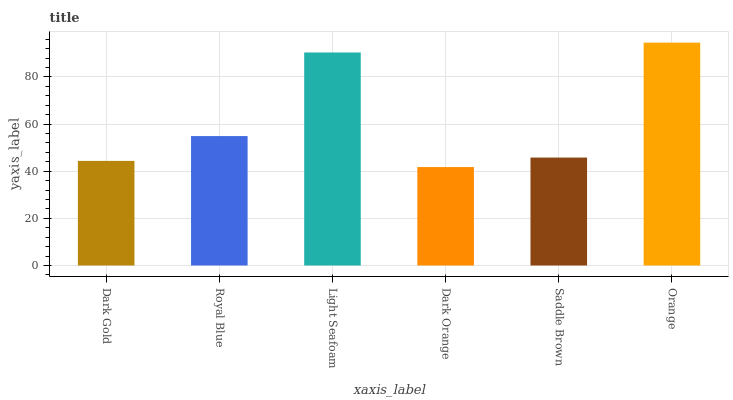Is Dark Orange the minimum?
Answer yes or no. Yes. Is Orange the maximum?
Answer yes or no. Yes. Is Royal Blue the minimum?
Answer yes or no. No. Is Royal Blue the maximum?
Answer yes or no. No. Is Royal Blue greater than Dark Gold?
Answer yes or no. Yes. Is Dark Gold less than Royal Blue?
Answer yes or no. Yes. Is Dark Gold greater than Royal Blue?
Answer yes or no. No. Is Royal Blue less than Dark Gold?
Answer yes or no. No. Is Royal Blue the high median?
Answer yes or no. Yes. Is Saddle Brown the low median?
Answer yes or no. Yes. Is Saddle Brown the high median?
Answer yes or no. No. Is Dark Orange the low median?
Answer yes or no. No. 